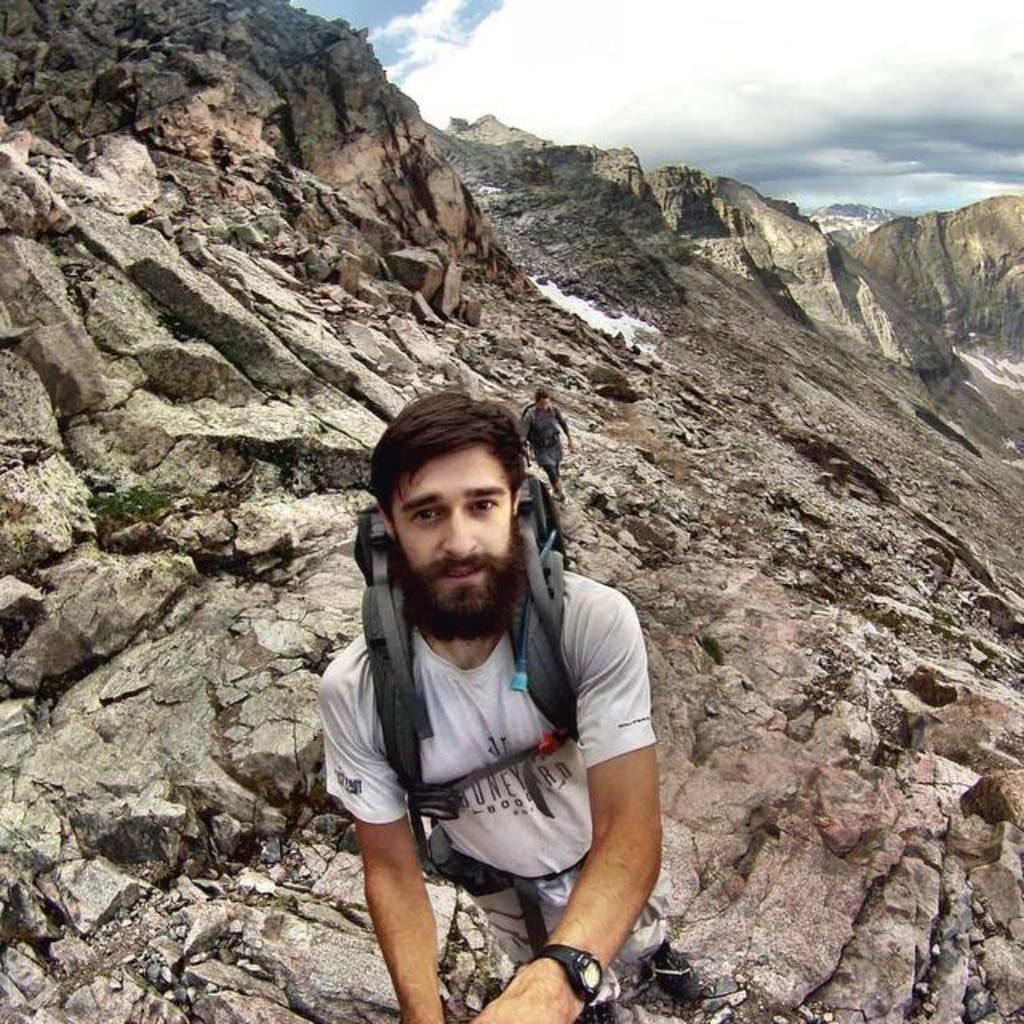What is the man in the foreground of the image wearing? The man is wearing a bag in the image. Can you describe the other man in the image? There is another man in the background of the image. What type of natural formation can be seen in the image? Rock hills are present in the image. What is visible in the sky in the image? The sky is visible in the image, and clouds are present in it. What type of chess piece is the man holding in the image? There is no chess piece present in the image; the man is wearing a bag. How low is the pipe in the image? There is no pipe present in the image. 